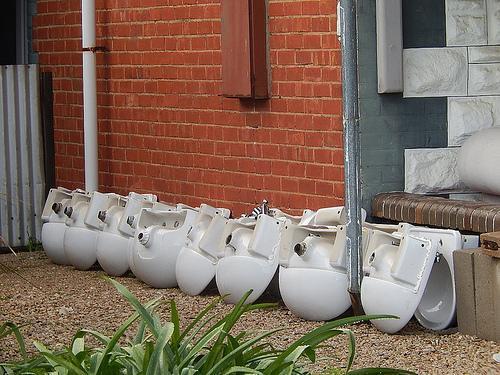How many plants are visible?
Give a very brief answer. 1. 